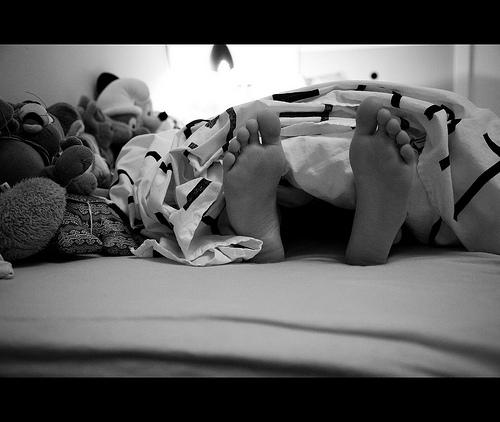Where are the stuffed animals located in the image? On the bed, near a person's feet and the blanket. Come up with an advertising slogan for the bed using the features in the image. "Sleep cozy and bright, surrounded by comfort and love with our luxurious bed and soft, colorful stuffed animals." What is a significant detail about the image that could be used to formulate a question for a multiple-choice VQA task? The presence of both a white blanket with black stripes and a brown teddy bear on the bed. Construct a multiple-choice question based on the image, along with three potential answers. Answer: B) A white blanket with black stripes and a brown teddy bear. Explain the relationship between the sunlight and an object in the image. The sun is shining through the window, casting a bright light onto the bed and its surroundings. Describe the position of the person's feet in relation to the blanket. A person's feet are sticking out from under the blanket on the bed, with one foot on each side of the blanket. Which object in the image would be most useful for a product advertisement, and why? The bed with appealing sheets and blankets because it looks comfortable, inviting, and shows the product in a natural setting. What is the main object in the image that the person is interacting with? A bed with sheets, blankets, and stuffed animals on it. List three actions that are taking place in the image. Feet sticking out from under a blanket, toes on the foot, and sunlight shining through the window. Locate an object in the image and describe its proximity to another object. A Mickey Mouse stuffed animal is on the bed, close to the person's feet sticking out from under the blanket. 